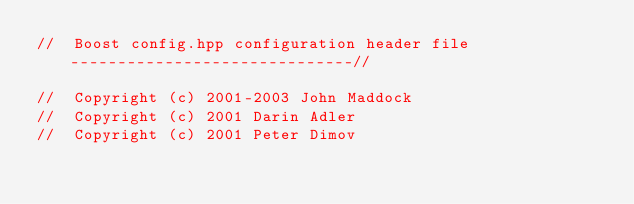Convert code to text. <code><loc_0><loc_0><loc_500><loc_500><_C++_>//  Boost config.hpp configuration header file  ------------------------------//

//  Copyright (c) 2001-2003 John Maddock
//  Copyright (c) 2001 Darin Adler
//  Copyright (c) 2001 Peter Dimov</code> 